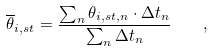Convert formula to latex. <formula><loc_0><loc_0><loc_500><loc_500>\overline { \theta } _ { i , s t } = \frac { \sum _ { n } \theta _ { i , s t , n } \cdot \Delta t _ { n } } { \sum _ { n } \Delta t _ { n } } \quad ,</formula> 